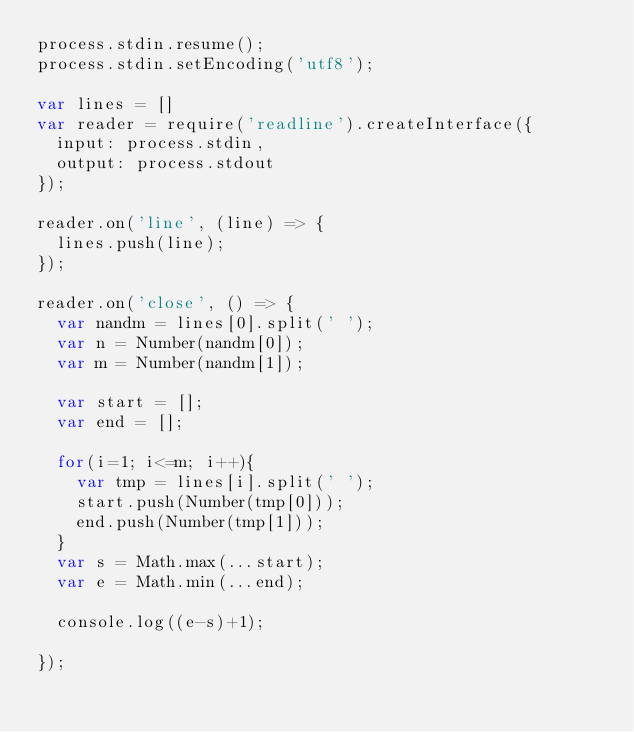<code> <loc_0><loc_0><loc_500><loc_500><_JavaScript_>process.stdin.resume();
process.stdin.setEncoding('utf8');

var lines = []
var reader = require('readline').createInterface({
  input: process.stdin,
  output: process.stdout
});

reader.on('line', (line) => {
  lines.push(line);
});

reader.on('close', () => {
  var nandm = lines[0].split(' ');
  var n = Number(nandm[0]);
  var m = Number(nandm[1]);

  var start = [];
  var end = [];

  for(i=1; i<=m; i++){
    var tmp = lines[i].split(' '); 
    start.push(Number(tmp[0]));
    end.push(Number(tmp[1]));
  }
  var s = Math.max(...start);
  var e = Math.min(...end);

  console.log((e-s)+1);
  
});
</code> 